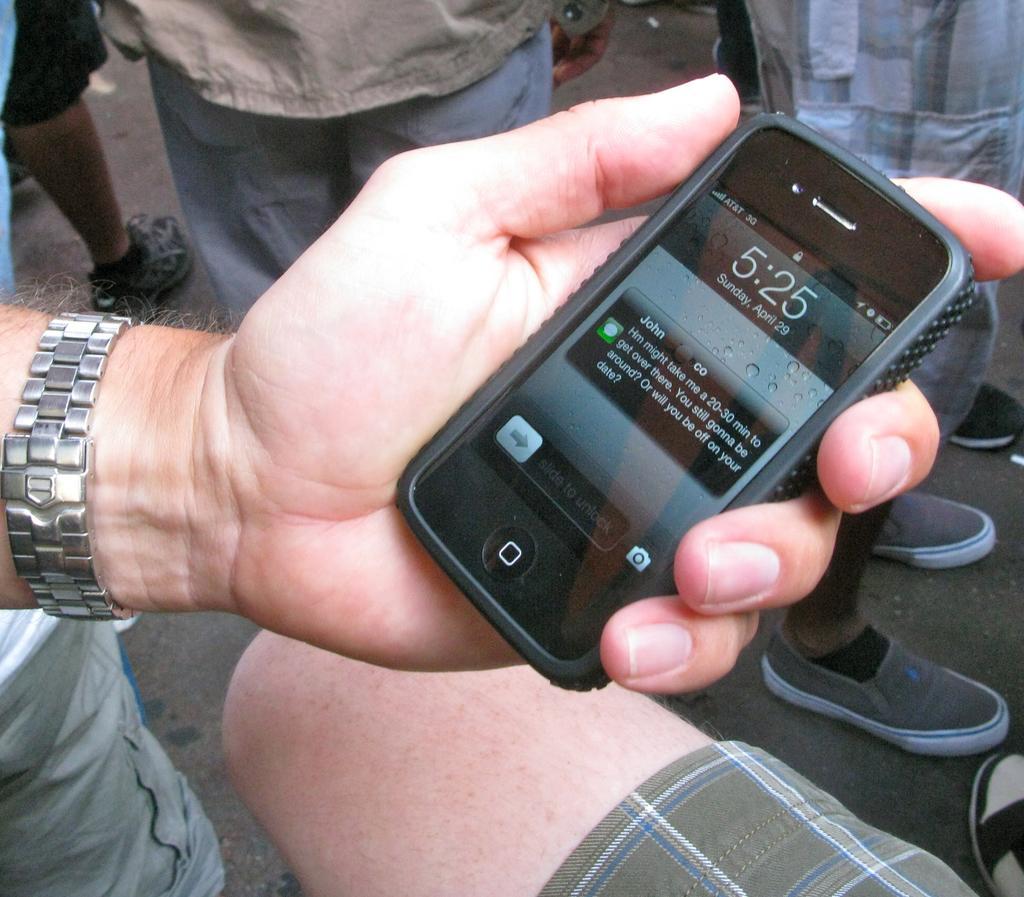Please provide a concise description of this image. In this image we can see a hand of a person holding a cellphone. On the backside we can see some people standing on the road. 